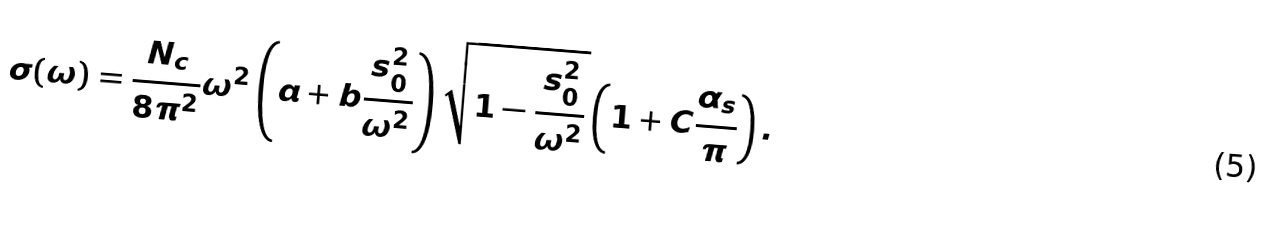<formula> <loc_0><loc_0><loc_500><loc_500>\sigma ( \omega ) = \frac { N _ { c } } { 8 \pi ^ { 2 } } \omega ^ { 2 } \left ( a + b \frac { s _ { 0 } ^ { 2 } } { \omega ^ { 2 } } \right ) \sqrt { 1 - \frac { s _ { 0 } ^ { 2 } } { \omega ^ { 2 } } } \left ( 1 + C \frac { \alpha _ { s } } { \pi } \right ) .</formula> 